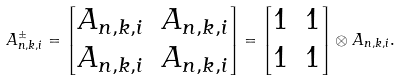<formula> <loc_0><loc_0><loc_500><loc_500>A ^ { \pm } _ { n , k , i } = \begin{bmatrix} A _ { n , k , i } & A _ { n , k , i } \\ A _ { n , k , i } & A _ { n , k , i } \end{bmatrix} = \begin{bmatrix} 1 & 1 \\ 1 & 1 \end{bmatrix} \otimes A _ { n , k , i } .</formula> 